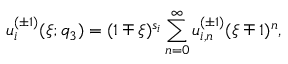Convert formula to latex. <formula><loc_0><loc_0><loc_500><loc_500>u _ { i } ^ { ( \pm 1 ) } ( \xi ; q _ { 3 } ) = ( 1 \mp \xi ) ^ { s _ { i } } \sum _ { n = 0 } ^ { \infty } u _ { i , n } ^ { ( \pm 1 ) } ( \xi \mp 1 ) ^ { n } ,</formula> 